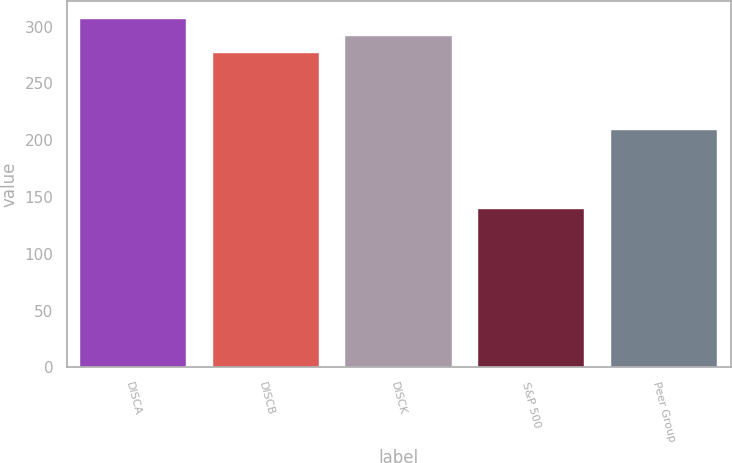Convert chart to OTSL. <chart><loc_0><loc_0><loc_500><loc_500><bar_chart><fcel>DISCA<fcel>DISCB<fcel>DISCK<fcel>S&P 500<fcel>Peer Group<nl><fcel>307.05<fcel>277.03<fcel>292.04<fcel>139.23<fcel>208.91<nl></chart> 